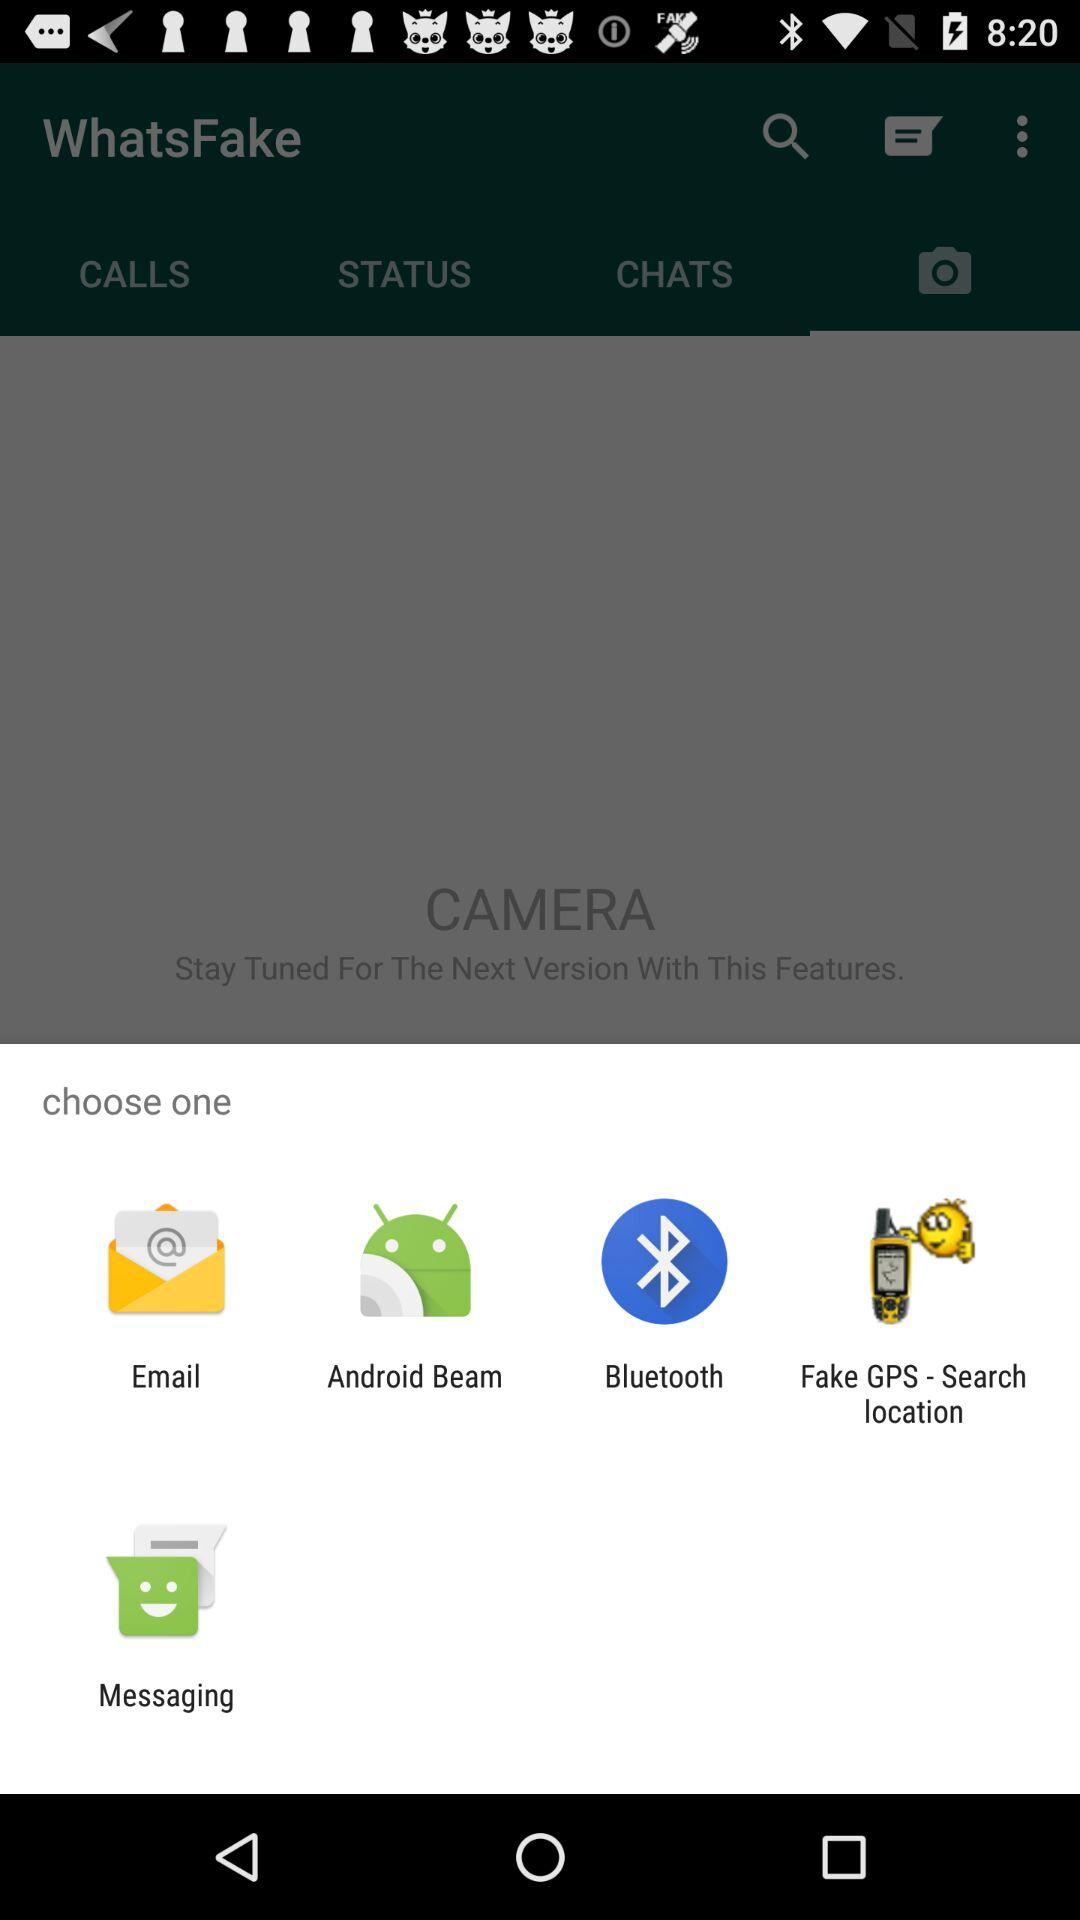Which tab is currently selected? The currently selected tab is "CAMERA". 